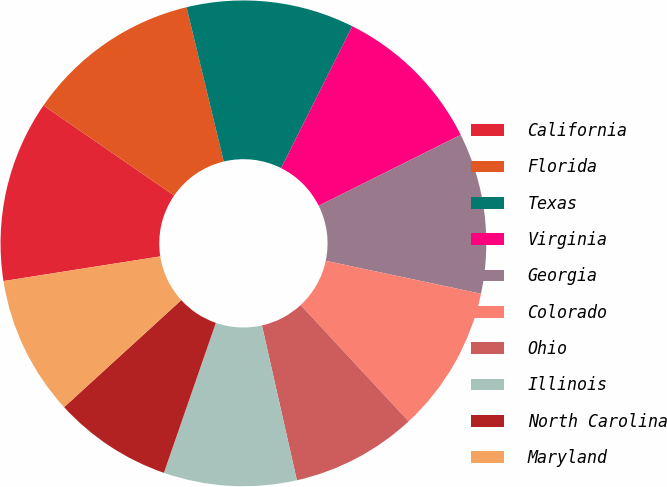<chart> <loc_0><loc_0><loc_500><loc_500><pie_chart><fcel>California<fcel>Florida<fcel>Texas<fcel>Virginia<fcel>Georgia<fcel>Colorado<fcel>Ohio<fcel>Illinois<fcel>North Carolina<fcel>Maryland<nl><fcel>12.09%<fcel>11.63%<fcel>11.16%<fcel>10.23%<fcel>10.7%<fcel>9.77%<fcel>8.37%<fcel>8.84%<fcel>7.91%<fcel>9.3%<nl></chart> 